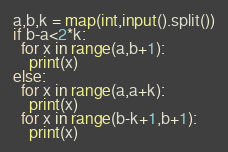Convert code to text. <code><loc_0><loc_0><loc_500><loc_500><_Python_>a,b,k = map(int,input().split())
if b-a<2*k:
  for x in range(a,b+1):
    print(x)
else:
  for x in range(a,a+k):
    print(x)
  for x in range(b-k+1,b+1):
    print(x)
</code> 